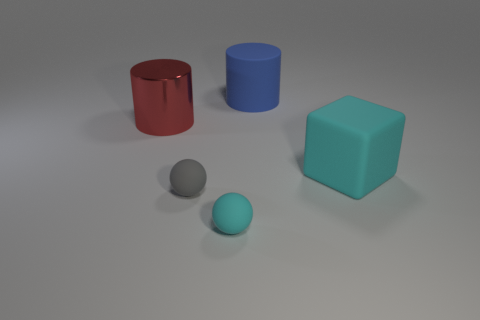Add 4 small cyan cylinders. How many objects exist? 9 Subtract 1 balls. How many balls are left? 1 Subtract all cyan spheres. How many spheres are left? 1 Subtract all big spheres. Subtract all blocks. How many objects are left? 4 Add 4 small balls. How many small balls are left? 6 Add 5 big blue rubber things. How many big blue rubber things exist? 6 Subtract 0 purple balls. How many objects are left? 5 Subtract all balls. How many objects are left? 3 Subtract all green cylinders. Subtract all green cubes. How many cylinders are left? 2 Subtract all cyan balls. How many brown cylinders are left? 0 